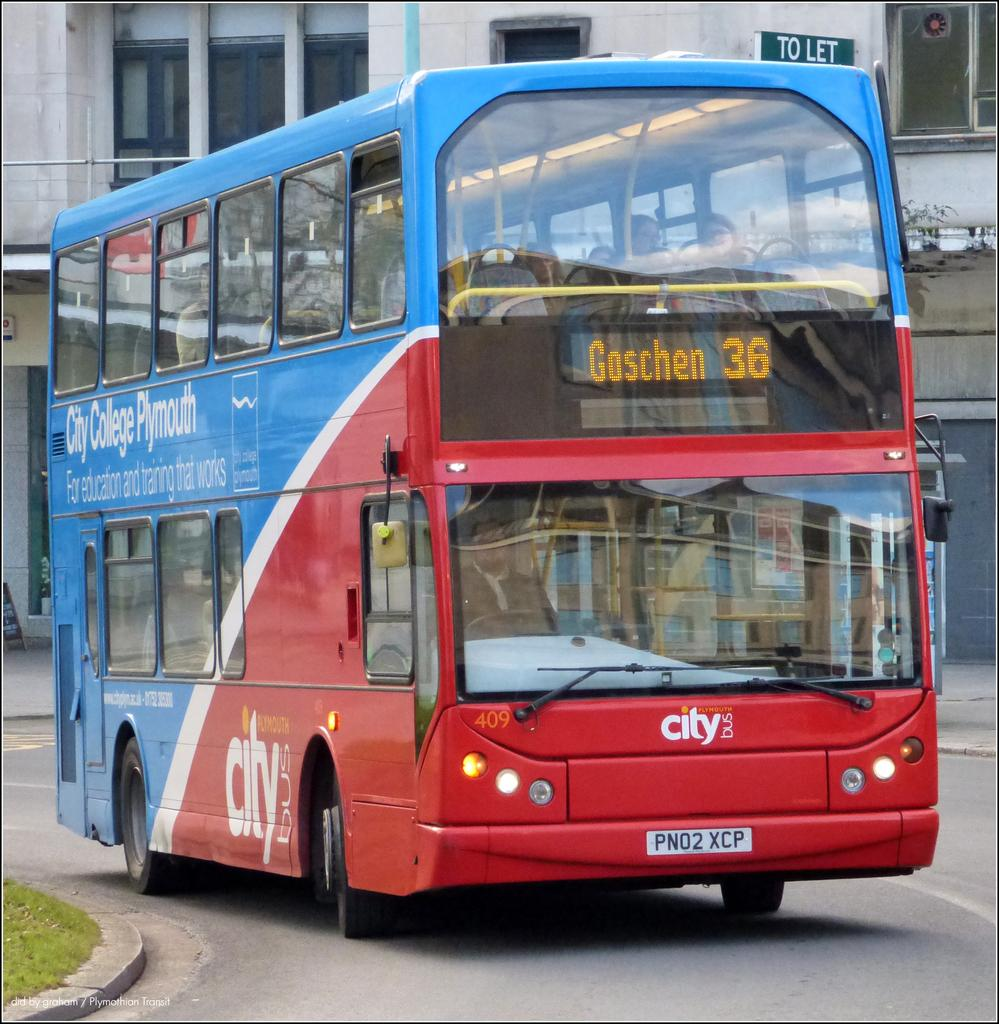<image>
Provide a brief description of the given image. A double decker bus that is going to Goschen. 